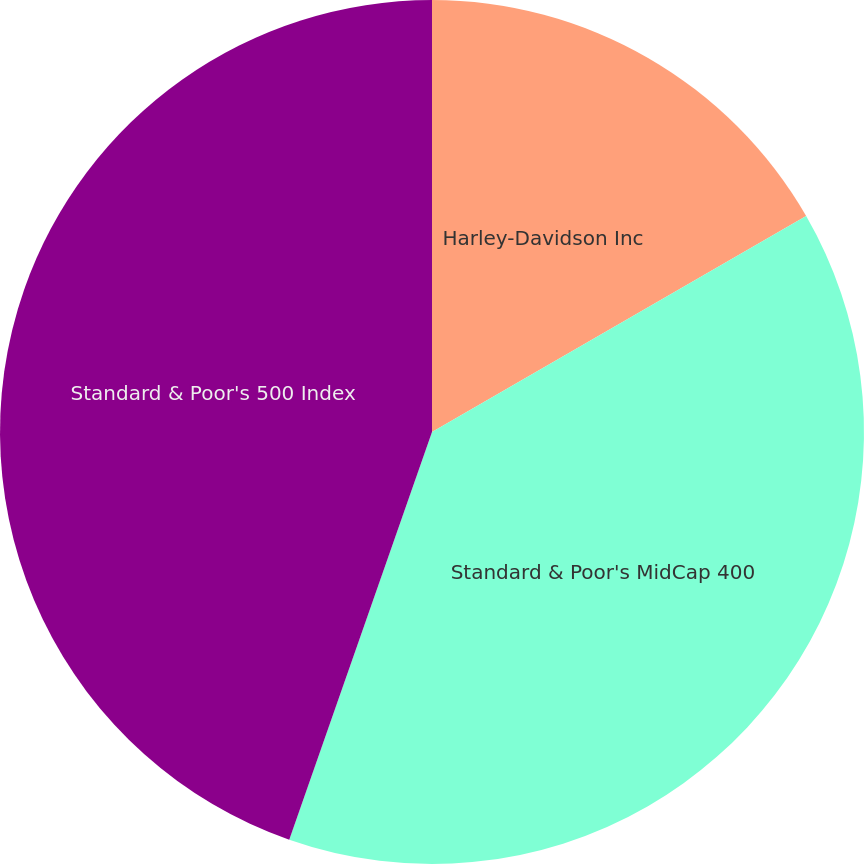Convert chart. <chart><loc_0><loc_0><loc_500><loc_500><pie_chart><fcel>Harley-Davidson Inc<fcel>Standard & Poor's MidCap 400<fcel>Standard & Poor's 500 Index<nl><fcel>16.67%<fcel>38.69%<fcel>44.64%<nl></chart> 